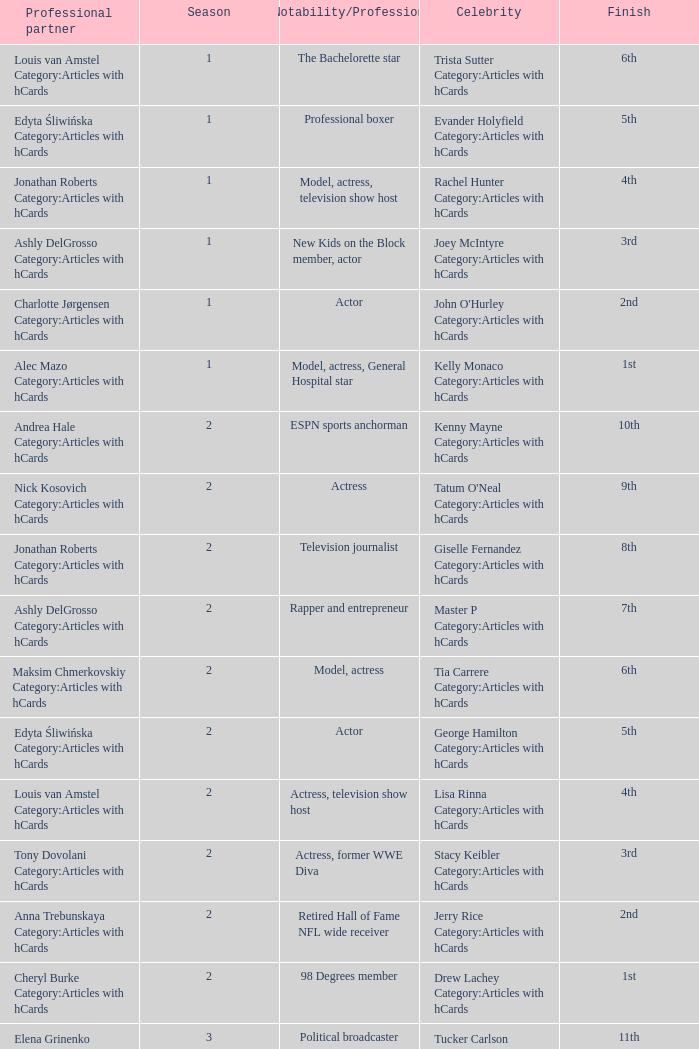What was the profession of the celebrity who was featured on season 15 and finished 7th place? Actress, comedian. 